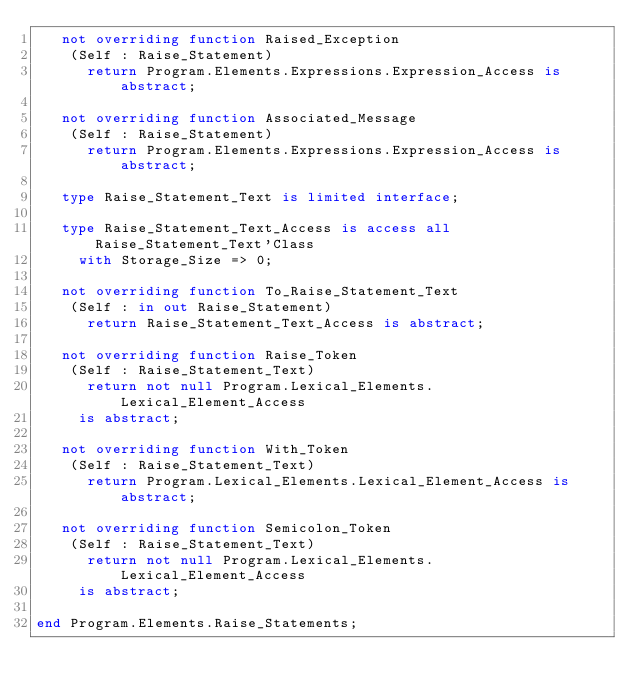<code> <loc_0><loc_0><loc_500><loc_500><_Ada_>   not overriding function Raised_Exception
    (Self : Raise_Statement)
      return Program.Elements.Expressions.Expression_Access is abstract;

   not overriding function Associated_Message
    (Self : Raise_Statement)
      return Program.Elements.Expressions.Expression_Access is abstract;

   type Raise_Statement_Text is limited interface;

   type Raise_Statement_Text_Access is access all Raise_Statement_Text'Class
     with Storage_Size => 0;

   not overriding function To_Raise_Statement_Text
    (Self : in out Raise_Statement)
      return Raise_Statement_Text_Access is abstract;

   not overriding function Raise_Token
    (Self : Raise_Statement_Text)
      return not null Program.Lexical_Elements.Lexical_Element_Access
     is abstract;

   not overriding function With_Token
    (Self : Raise_Statement_Text)
      return Program.Lexical_Elements.Lexical_Element_Access is abstract;

   not overriding function Semicolon_Token
    (Self : Raise_Statement_Text)
      return not null Program.Lexical_Elements.Lexical_Element_Access
     is abstract;

end Program.Elements.Raise_Statements;
</code> 